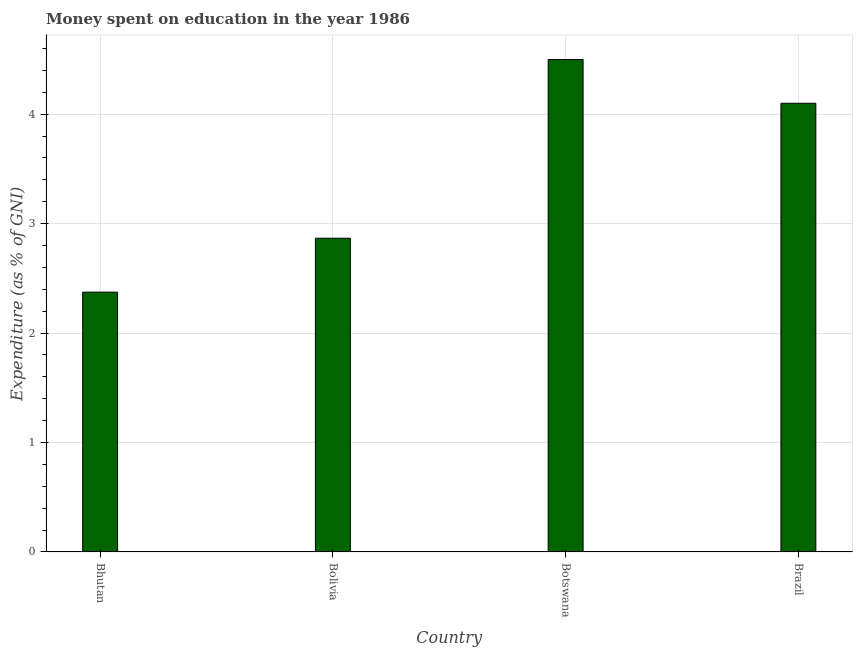Does the graph contain grids?
Keep it short and to the point. Yes. What is the title of the graph?
Keep it short and to the point. Money spent on education in the year 1986. What is the label or title of the X-axis?
Make the answer very short. Country. What is the label or title of the Y-axis?
Provide a short and direct response. Expenditure (as % of GNI). What is the expenditure on education in Brazil?
Provide a succinct answer. 4.1. Across all countries, what is the maximum expenditure on education?
Ensure brevity in your answer.  4.5. Across all countries, what is the minimum expenditure on education?
Provide a succinct answer. 2.37. In which country was the expenditure on education maximum?
Your response must be concise. Botswana. In which country was the expenditure on education minimum?
Keep it short and to the point. Bhutan. What is the sum of the expenditure on education?
Make the answer very short. 13.84. What is the difference between the expenditure on education in Bolivia and Botswana?
Give a very brief answer. -1.63. What is the average expenditure on education per country?
Your answer should be very brief. 3.46. What is the median expenditure on education?
Provide a short and direct response. 3.48. What is the ratio of the expenditure on education in Bolivia to that in Botswana?
Your response must be concise. 0.64. Is the expenditure on education in Botswana less than that in Brazil?
Provide a succinct answer. No. Is the difference between the expenditure on education in Bhutan and Botswana greater than the difference between any two countries?
Your answer should be compact. Yes. What is the difference between the highest and the second highest expenditure on education?
Give a very brief answer. 0.4. Is the sum of the expenditure on education in Bolivia and Botswana greater than the maximum expenditure on education across all countries?
Offer a very short reply. Yes. What is the difference between the highest and the lowest expenditure on education?
Provide a short and direct response. 2.13. How many countries are there in the graph?
Ensure brevity in your answer.  4. Are the values on the major ticks of Y-axis written in scientific E-notation?
Your response must be concise. No. What is the Expenditure (as % of GNI) of Bhutan?
Offer a terse response. 2.37. What is the Expenditure (as % of GNI) in Bolivia?
Offer a very short reply. 2.87. What is the Expenditure (as % of GNI) of Brazil?
Offer a terse response. 4.1. What is the difference between the Expenditure (as % of GNI) in Bhutan and Bolivia?
Keep it short and to the point. -0.49. What is the difference between the Expenditure (as % of GNI) in Bhutan and Botswana?
Offer a very short reply. -2.13. What is the difference between the Expenditure (as % of GNI) in Bhutan and Brazil?
Offer a terse response. -1.73. What is the difference between the Expenditure (as % of GNI) in Bolivia and Botswana?
Give a very brief answer. -1.63. What is the difference between the Expenditure (as % of GNI) in Bolivia and Brazil?
Provide a succinct answer. -1.23. What is the difference between the Expenditure (as % of GNI) in Botswana and Brazil?
Your answer should be very brief. 0.4. What is the ratio of the Expenditure (as % of GNI) in Bhutan to that in Bolivia?
Keep it short and to the point. 0.83. What is the ratio of the Expenditure (as % of GNI) in Bhutan to that in Botswana?
Give a very brief answer. 0.53. What is the ratio of the Expenditure (as % of GNI) in Bhutan to that in Brazil?
Keep it short and to the point. 0.58. What is the ratio of the Expenditure (as % of GNI) in Bolivia to that in Botswana?
Offer a terse response. 0.64. What is the ratio of the Expenditure (as % of GNI) in Bolivia to that in Brazil?
Give a very brief answer. 0.7. What is the ratio of the Expenditure (as % of GNI) in Botswana to that in Brazil?
Ensure brevity in your answer.  1.1. 